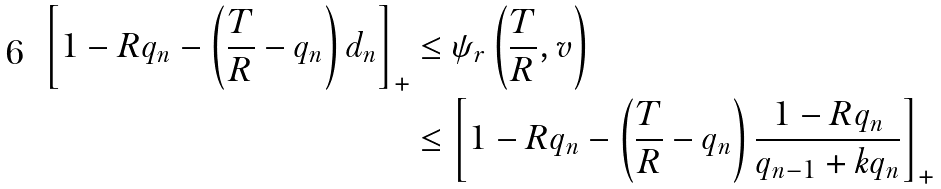<formula> <loc_0><loc_0><loc_500><loc_500>\left [ 1 - R q _ { n } - \left ( \frac { T } { R } - q _ { n } \right ) d _ { n } \right ] _ { + } & \leq \psi _ { r } \left ( \frac { T } { R } , v \right ) \\ & \leq \left [ 1 - R q _ { n } - \left ( \frac { T } { R } - q _ { n } \right ) \frac { 1 - R q _ { n } } { q _ { n - 1 } + k q _ { n } } \right ] _ { + }</formula> 